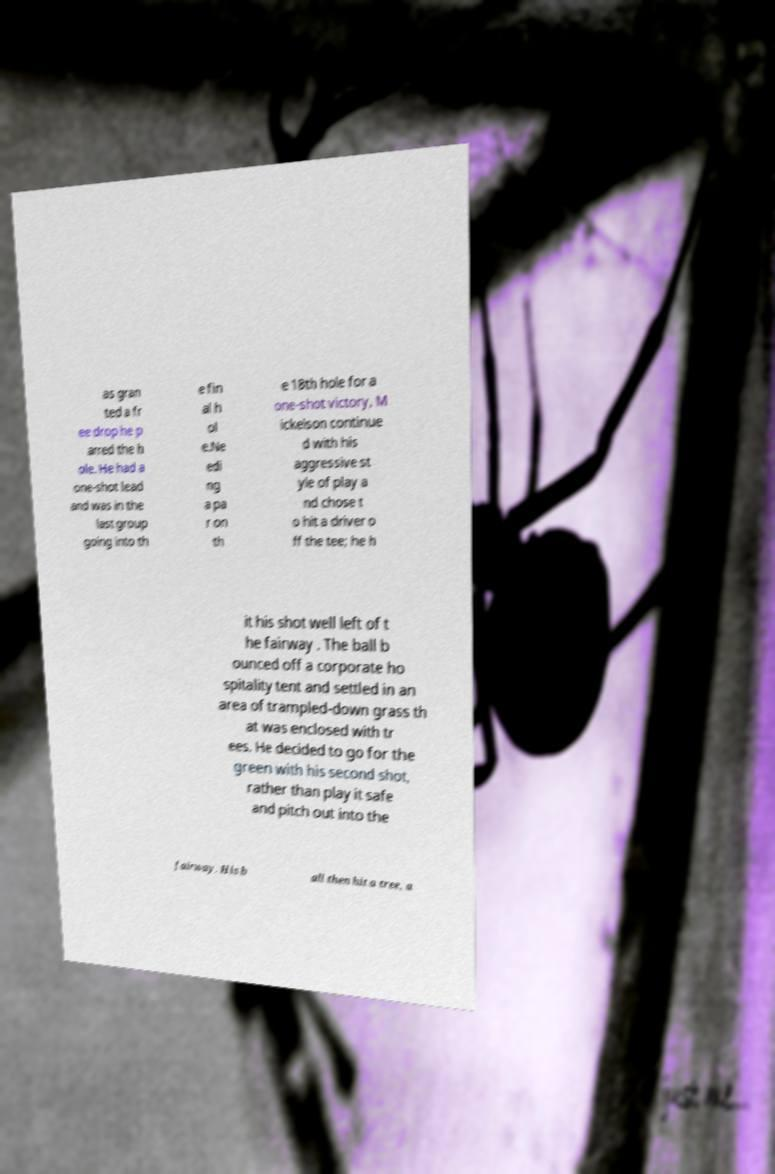Can you accurately transcribe the text from the provided image for me? as gran ted a fr ee drop he p arred the h ole. He had a one-shot lead and was in the last group going into th e fin al h ol e.Ne edi ng a pa r on th e 18th hole for a one-shot victory, M ickelson continue d with his aggressive st yle of play a nd chose t o hit a driver o ff the tee; he h it his shot well left of t he fairway . The ball b ounced off a corporate ho spitality tent and settled in an area of trampled-down grass th at was enclosed with tr ees. He decided to go for the green with his second shot, rather than play it safe and pitch out into the fairway. His b all then hit a tree, a 